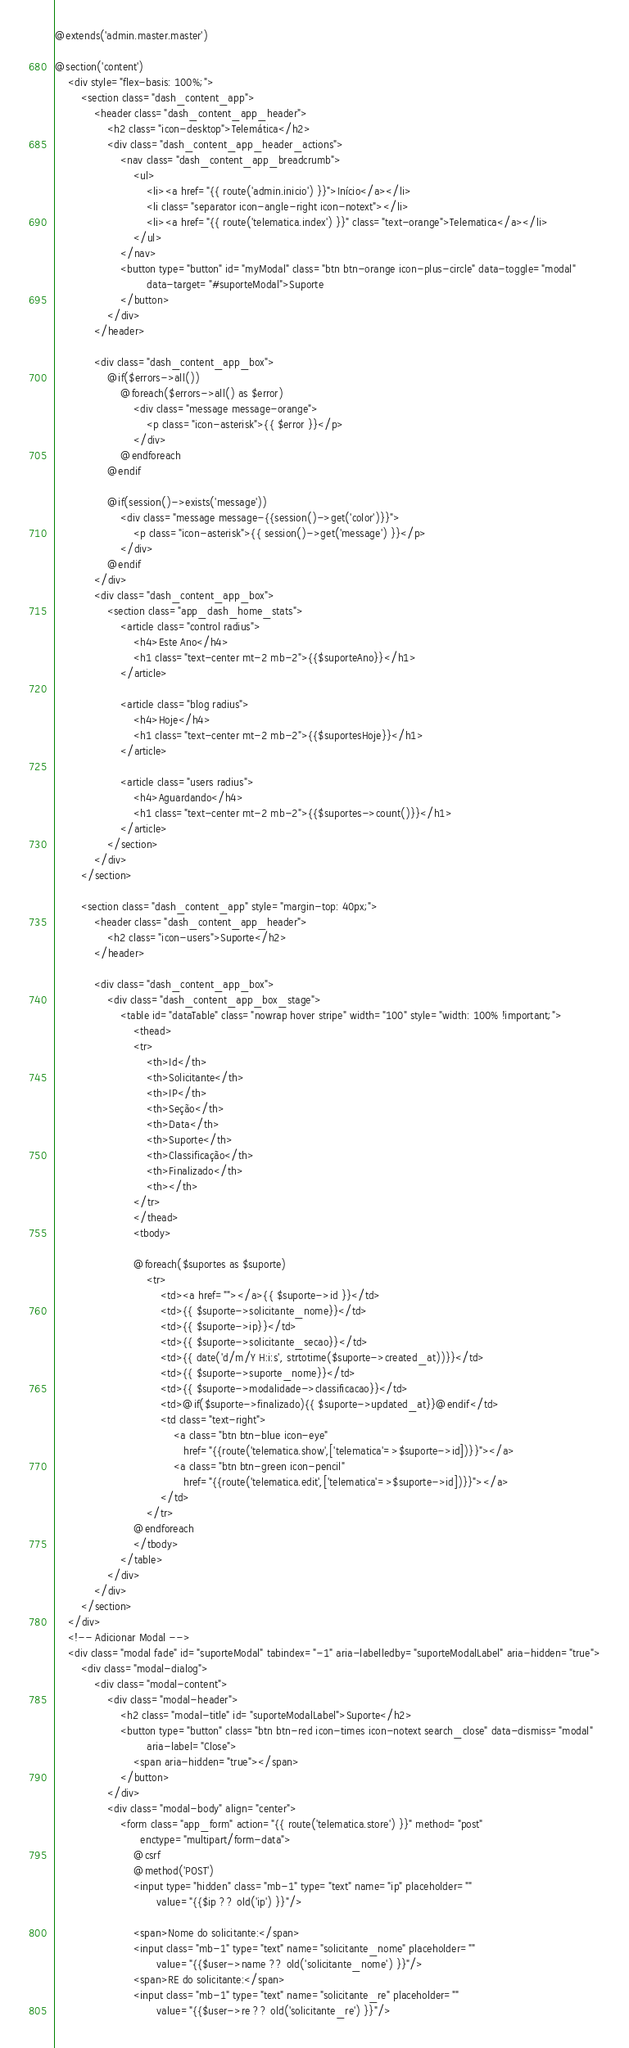<code> <loc_0><loc_0><loc_500><loc_500><_PHP_>@extends('admin.master.master')

@section('content')
    <div style="flex-basis: 100%;">
        <section class="dash_content_app">
            <header class="dash_content_app_header">
                <h2 class="icon-desktop">Telemática</h2>
                <div class="dash_content_app_header_actions">
                    <nav class="dash_content_app_breadcrumb">
                        <ul>
                            <li><a href="{{ route('admin.inicio') }}">Início</a></li>
                            <li class="separator icon-angle-right icon-notext"></li>
                            <li><a href="{{ route('telematica.index') }}" class="text-orange">Telematica</a></li>
                        </ul>
                    </nav>
                    <button type="button" id="myModal" class="btn btn-orange icon-plus-circle" data-toggle="modal"
                            data-target="#suporteModal">Suporte
                    </button>
                </div>
            </header>

            <div class="dash_content_app_box">
                @if($errors->all())
                    @foreach($errors->all() as $error)
                        <div class="message message-orange">
                            <p class="icon-asterisk">{{ $error }}</p>
                        </div>
                    @endforeach
                @endif

                @if(session()->exists('message'))
                    <div class="message message-{{session()->get('color')}}">
                        <p class="icon-asterisk">{{ session()->get('message') }}</p>
                    </div>
                @endif
            </div>
            <div class="dash_content_app_box">
                <section class="app_dash_home_stats">
                    <article class="control radius">
                        <h4>Este Ano</h4>
                        <h1 class="text-center mt-2 mb-2">{{$suporteAno}}</h1>
                    </article>

                    <article class="blog radius">
                        <h4>Hoje</h4>
                        <h1 class="text-center mt-2 mb-2">{{$suportesHoje}}</h1>
                    </article>

                    <article class="users radius">
                        <h4>Aguardando</h4>
                        <h1 class="text-center mt-2 mb-2">{{$suportes->count()}}</h1>
                    </article>
                </section>
            </div>
        </section>

        <section class="dash_content_app" style="margin-top: 40px;">
            <header class="dash_content_app_header">
                <h2 class="icon-users">Suporte</h2>
            </header>

            <div class="dash_content_app_box">
                <div class="dash_content_app_box_stage">
                    <table id="dataTable" class="nowrap hover stripe" width="100" style="width: 100% !important;">
                        <thead>
                        <tr>
                            <th>Id</th>
                            <th>Solicitante</th>
                            <th>IP</th>
                            <th>Seção</th>
                            <th>Data</th>
                            <th>Suporte</th>
                            <th>Classificação</th>
                            <th>Finalizado</th>
                            <th></th>
                        </tr>
                        </thead>
                        <tbody>

                        @foreach($suportes as $suporte)
                            <tr>
                                <td><a href=""></a>{{ $suporte->id }}</td>
                                <td>{{ $suporte->solicitante_nome}}</td>
                                <td>{{ $suporte->ip}}</td>
                                <td>{{ $suporte->solicitante_secao}}</td>
                                <td>{{ date('d/m/Y H:i:s', strtotime($suporte->created_at))}}</td>
                                <td>{{ $suporte->suporte_nome}}</td>
                                <td>{{ $suporte->modalidade->classificacao}}</td>
                                <td>@if($suporte->finalizado){{ $suporte->updated_at}}@endif</td>
                                <td class="text-right">
                                    <a class="btn btn-blue icon-eye"
                                       href="{{route('telematica.show',['telematica'=>$suporte->id])}}"></a>
                                    <a class="btn btn-green icon-pencil"
                                       href="{{route('telematica.edit',['telematica'=>$suporte->id])}}"></a>
                                </td>
                            </tr>
                        @endforeach
                        </tbody>
                    </table>
                </div>
            </div>
        </section>
    </div>
    <!-- Adicionar Modal -->
    <div class="modal fade" id="suporteModal" tabindex="-1" aria-labelledby="suporteModalLabel" aria-hidden="true">
        <div class="modal-dialog">
            <div class="modal-content">
                <div class="modal-header">
                    <h2 class="modal-title" id="suporteModalLabel">Suporte</h2>
                    <button type="button" class="btn btn-red icon-times icon-notext search_close" data-dismiss="modal"
                            aria-label="Close">
                        <span aria-hidden="true"></span>
                    </button>
                </div>
                <div class="modal-body" align="center">
                    <form class="app_form" action="{{ route('telematica.store') }}" method="post"
                          enctype="multipart/form-data">
                        @csrf
                        @method('POST')
                        <input type="hidden" class="mb-1" type="text" name="ip" placeholder=""
                               value="{{$ip ?? old('ip') }}"/>

                        <span>Nome do solicitante:</span>
                        <input class="mb-1" type="text" name="solicitante_nome" placeholder=""
                               value="{{$user->name ?? old('solicitante_nome') }}"/>
                        <span>RE do solicitante:</span>
                        <input class="mb-1" type="text" name="solicitante_re" placeholder=""
                               value="{{$user->re ?? old('solicitante_re') }}"/></code> 